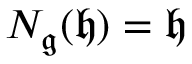<formula> <loc_0><loc_0><loc_500><loc_500>N _ { \mathfrak { g } } ( { \mathfrak { h } } ) = { \mathfrak { h } }</formula> 